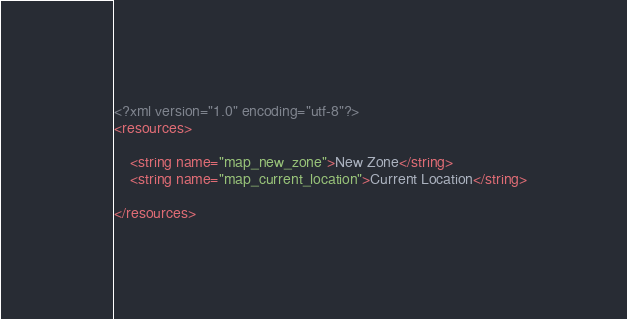Convert code to text. <code><loc_0><loc_0><loc_500><loc_500><_XML_><?xml version="1.0" encoding="utf-8"?>
<resources>

    <string name="map_new_zone">New Zone</string>
    <string name="map_current_location">Current Location</string>

</resources></code> 